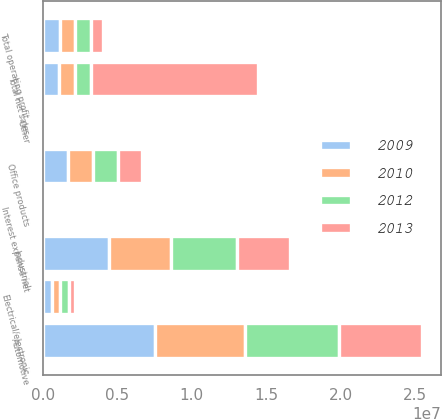<chart> <loc_0><loc_0><loc_500><loc_500><stacked_bar_chart><ecel><fcel>Automotive<fcel>Industrial<fcel>Office products<fcel>Electrical/electronic<fcel>Other<fcel>Total net sales<fcel>Total operating profit<fcel>Interest expense net<nl><fcel>2009<fcel>7.48919e+06<fcel>4.42998e+06<fcel>1.63862e+06<fcel>568872<fcel>48809<fcel>1.07815e+06<fcel>1.13229e+06<fcel>24330<nl><fcel>2012<fcel>6.32088e+06<fcel>4.45357e+06<fcel>1.68669e+06<fcel>582820<fcel>30098<fcel>1.07815e+06<fcel>1.07815e+06<fcel>19619<nl><fcel>2010<fcel>6.06142e+06<fcel>4.17357e+06<fcel>1.68937e+06<fcel>557537<fcel>23026<fcel>1.07815e+06<fcel>980221<fcel>24608<nl><fcel>2013<fcel>5.6081e+06<fcel>3.52186e+06<fcel>1.64196e+06<fcel>449770<fcel>14108<fcel>1.12076e+07<fcel>839381<fcel>26598<nl></chart> 